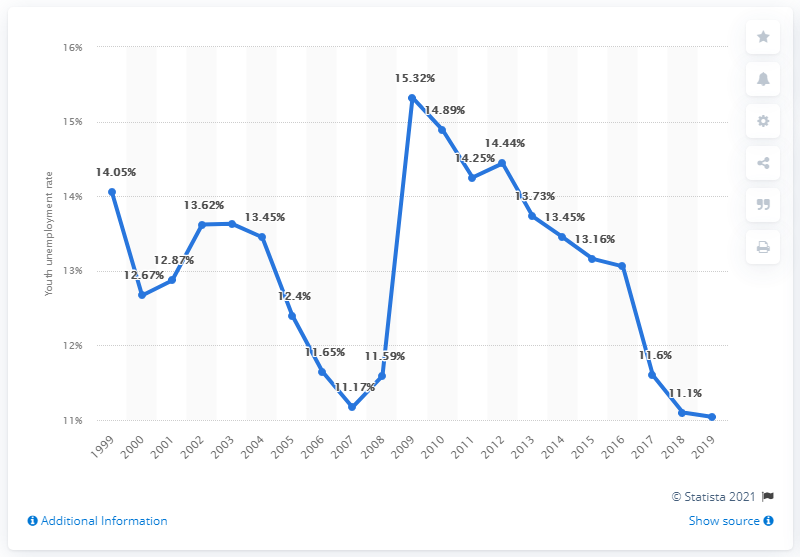Give some essential details in this illustration. In 2019, the youth unemployment rate in Canada was 11.04%. 